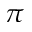<formula> <loc_0><loc_0><loc_500><loc_500>\pi</formula> 